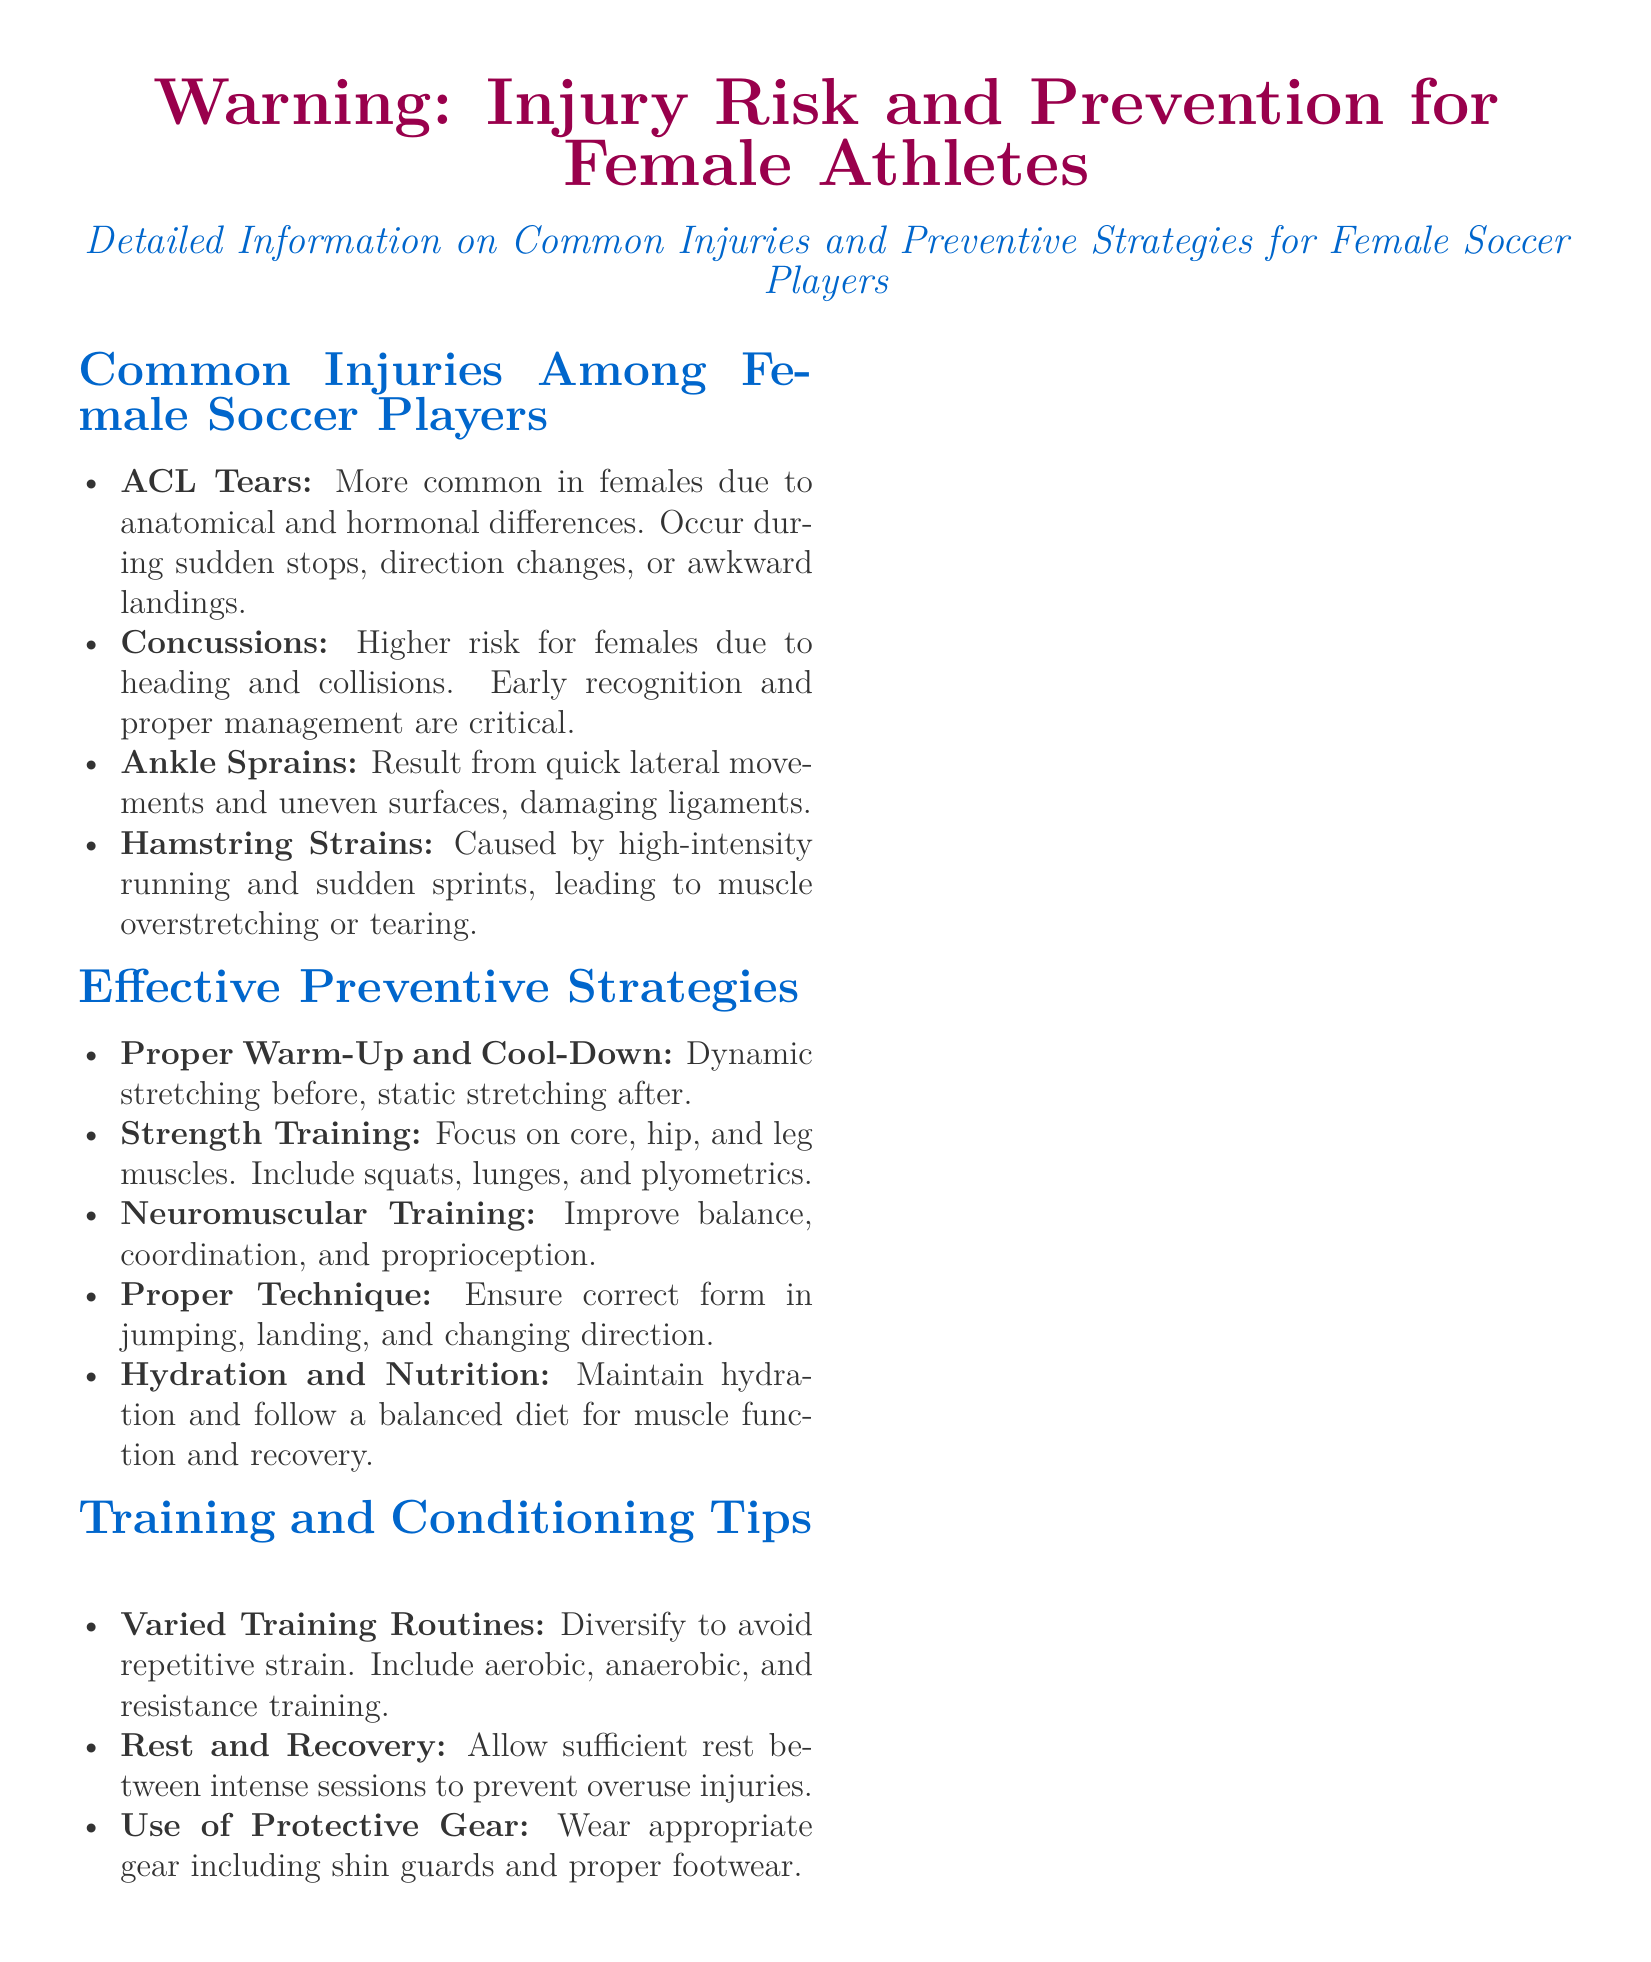What are the common injuries among female soccer players? The document lists four common injuries that female soccer players sustain.
Answer: ACL Tears, Concussions, Ankle Sprains, Hamstring Strains What is one effective preventive strategy mentioned? The document includes a list of preventive strategies; one example is the proper warm-up and cool-down.
Answer: Proper Warm-Up and Cool-Down Which injury is more common in females due to anatomical differences? The document specifically states that ACL tears are more common in females because of anatomical and hormonal differences.
Answer: ACL Tears What type of training should be included for prevention? The document advises strength training as one of the effective preventive strategies.
Answer: Strength Training What is emphasized for recovery and injury prevention in the training tips? The document highlights the importance of rest and recovery between intense sessions.
Answer: Rest and Recovery What disclaimer is mentioned in the document? The document contains a disclaimer stating that the information is not a substitute for professional advice.
Answer: This label provides general information and is not a substitute for professional advice Which training component focuses on balance and coordination? The document mentions neuromuscular training as a strategy to improve balance, coordination, and proprioception.
Answer: Neuromuscular Training What item of protective gear is recommended? The document suggests the use of protective gear such as shin guards.
Answer: Shin Guards 